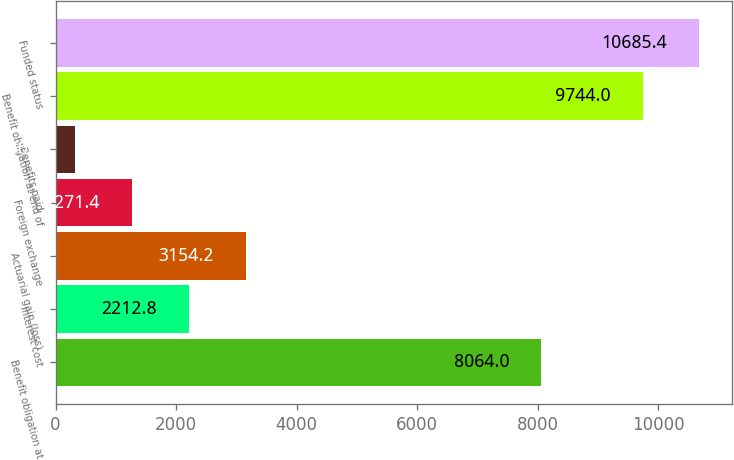Convert chart to OTSL. <chart><loc_0><loc_0><loc_500><loc_500><bar_chart><fcel>Benefit obligation at<fcel>Interest cost<fcel>Actuarial gain (loss)<fcel>Foreign exchange<fcel>Benefits paid<fcel>Benefit obligation at end of<fcel>Funded status<nl><fcel>8064<fcel>2212.8<fcel>3154.2<fcel>1271.4<fcel>330<fcel>9744<fcel>10685.4<nl></chart> 